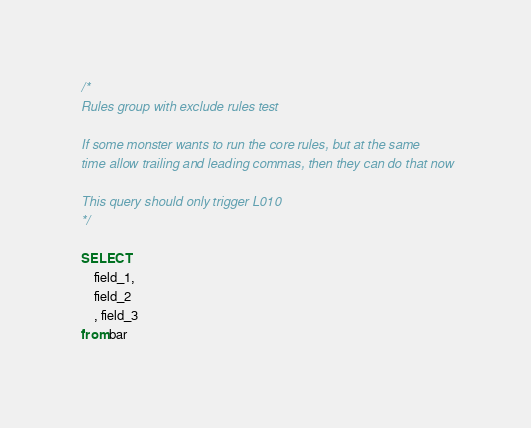Convert code to text. <code><loc_0><loc_0><loc_500><loc_500><_SQL_>
/*
Rules group with exclude rules test

If some monster wants to run the core rules, but at the same
time allow trailing and leading commas, then they can do that now

This query should only trigger L010
*/

SELECT
    field_1,
    field_2
    , field_3
from bar
</code> 